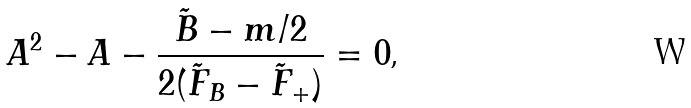Convert formula to latex. <formula><loc_0><loc_0><loc_500><loc_500>A ^ { 2 } - A - \frac { \tilde { B } - m / 2 } { 2 ( \tilde { F } _ { B } - \tilde { F } _ { + } ) } = 0 \text {,}</formula> 